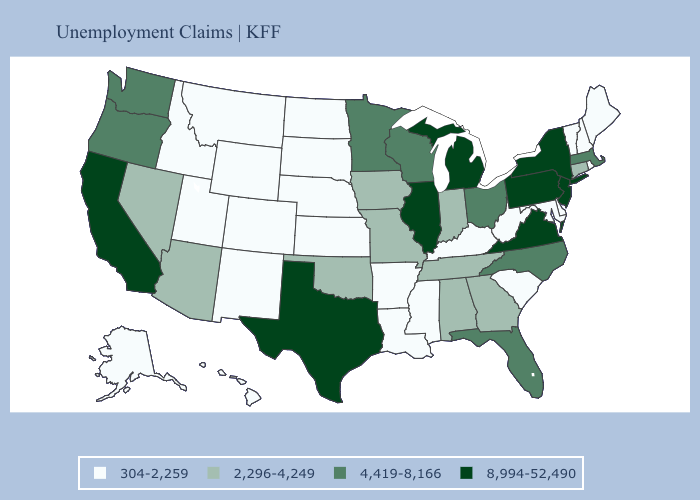Does the first symbol in the legend represent the smallest category?
Short answer required. Yes. Does Kansas have a lower value than Rhode Island?
Quick response, please. No. What is the value of Kansas?
Concise answer only. 304-2,259. What is the value of Texas?
Quick response, please. 8,994-52,490. Which states hav the highest value in the Northeast?
Answer briefly. New Jersey, New York, Pennsylvania. Name the states that have a value in the range 2,296-4,249?
Concise answer only. Alabama, Arizona, Connecticut, Georgia, Indiana, Iowa, Missouri, Nevada, Oklahoma, Tennessee. What is the value of Massachusetts?
Give a very brief answer. 4,419-8,166. Does North Dakota have a lower value than Montana?
Short answer required. No. What is the value of New York?
Short answer required. 8,994-52,490. What is the lowest value in states that border Iowa?
Be succinct. 304-2,259. Does Texas have the highest value in the South?
Write a very short answer. Yes. What is the highest value in the USA?
Short answer required. 8,994-52,490. Does Virginia have the lowest value in the South?
Keep it brief. No. What is the value of Missouri?
Keep it brief. 2,296-4,249. What is the value of Michigan?
Concise answer only. 8,994-52,490. 